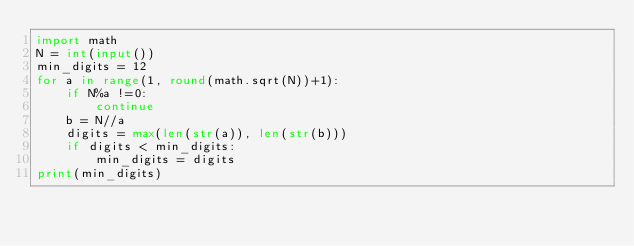Convert code to text. <code><loc_0><loc_0><loc_500><loc_500><_Python_>import math
N = int(input())
min_digits = 12
for a in range(1, round(math.sqrt(N))+1):
    if N%a !=0:
        continue
    b = N//a
    digits = max(len(str(a)), len(str(b)))
    if digits < min_digits:
        min_digits = digits
print(min_digits)</code> 